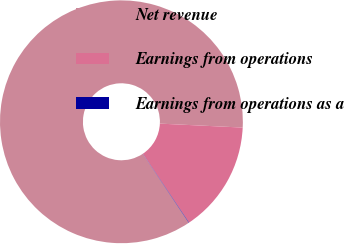<chart> <loc_0><loc_0><loc_500><loc_500><pie_chart><fcel>Net revenue<fcel>Earnings from operations<fcel>Earnings from operations as a<nl><fcel>85.11%<fcel>14.84%<fcel>0.05%<nl></chart> 